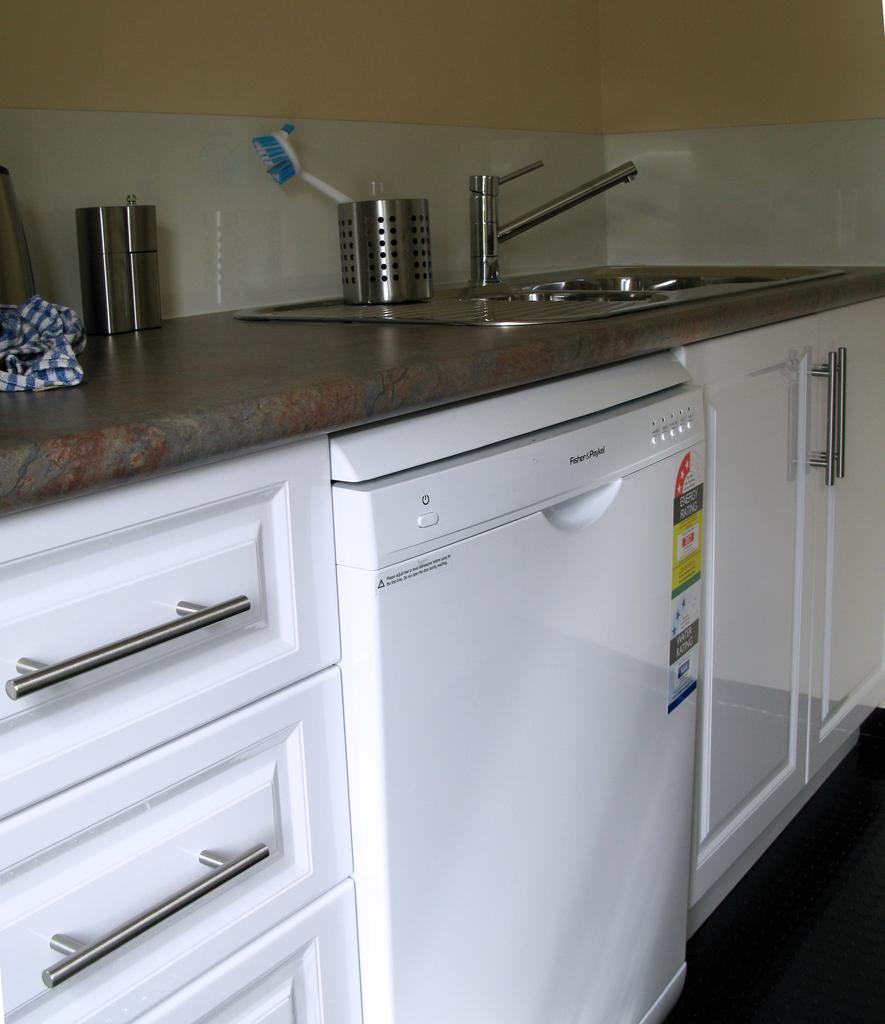Please provide a concise description of this image. In this image I can see a table cabinets. On the table I can see a tap, bowls and a cloth. At the top I can see the wall. 